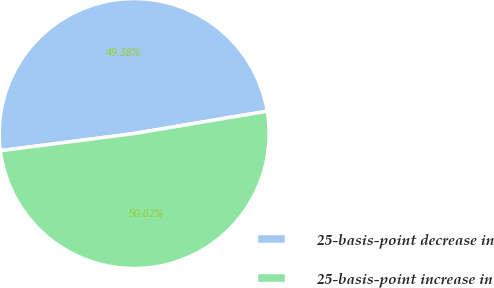Convert chart. <chart><loc_0><loc_0><loc_500><loc_500><pie_chart><fcel>25-basis-point decrease in<fcel>25-basis-point increase in<nl><fcel>49.38%<fcel>50.62%<nl></chart> 